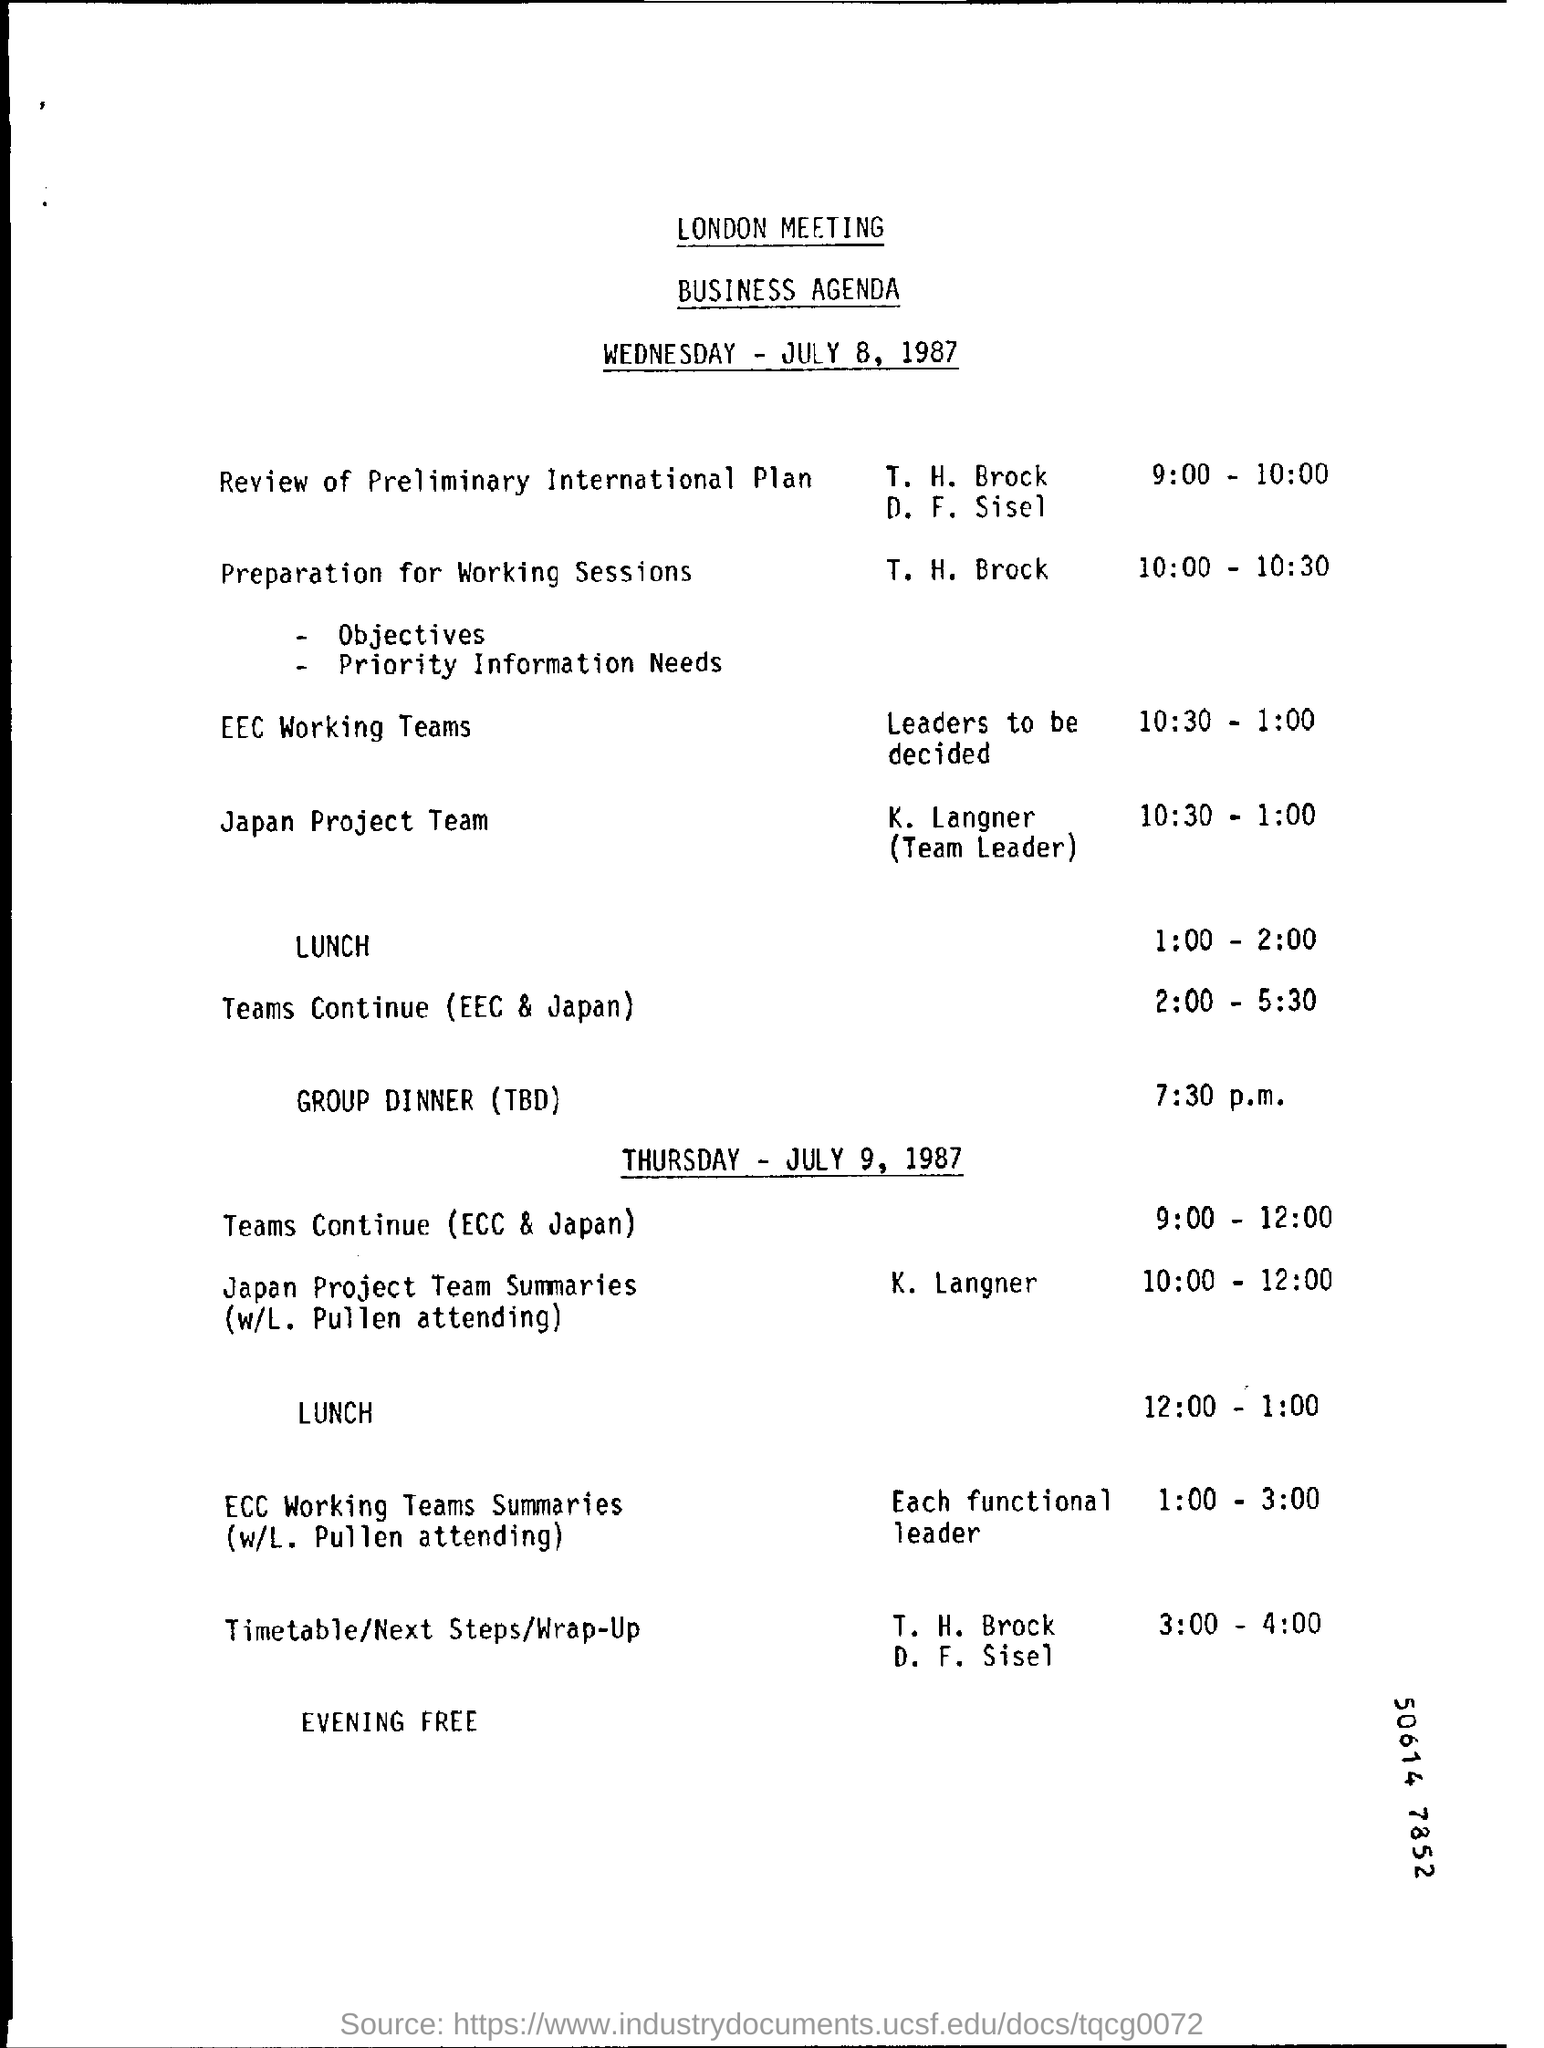Who will do the preparation for Working Sessions?
Your answer should be compact. T. H. Brock. What is the event from 10:30 - 1:00?
Provide a short and direct response. EEC Working Teams. 